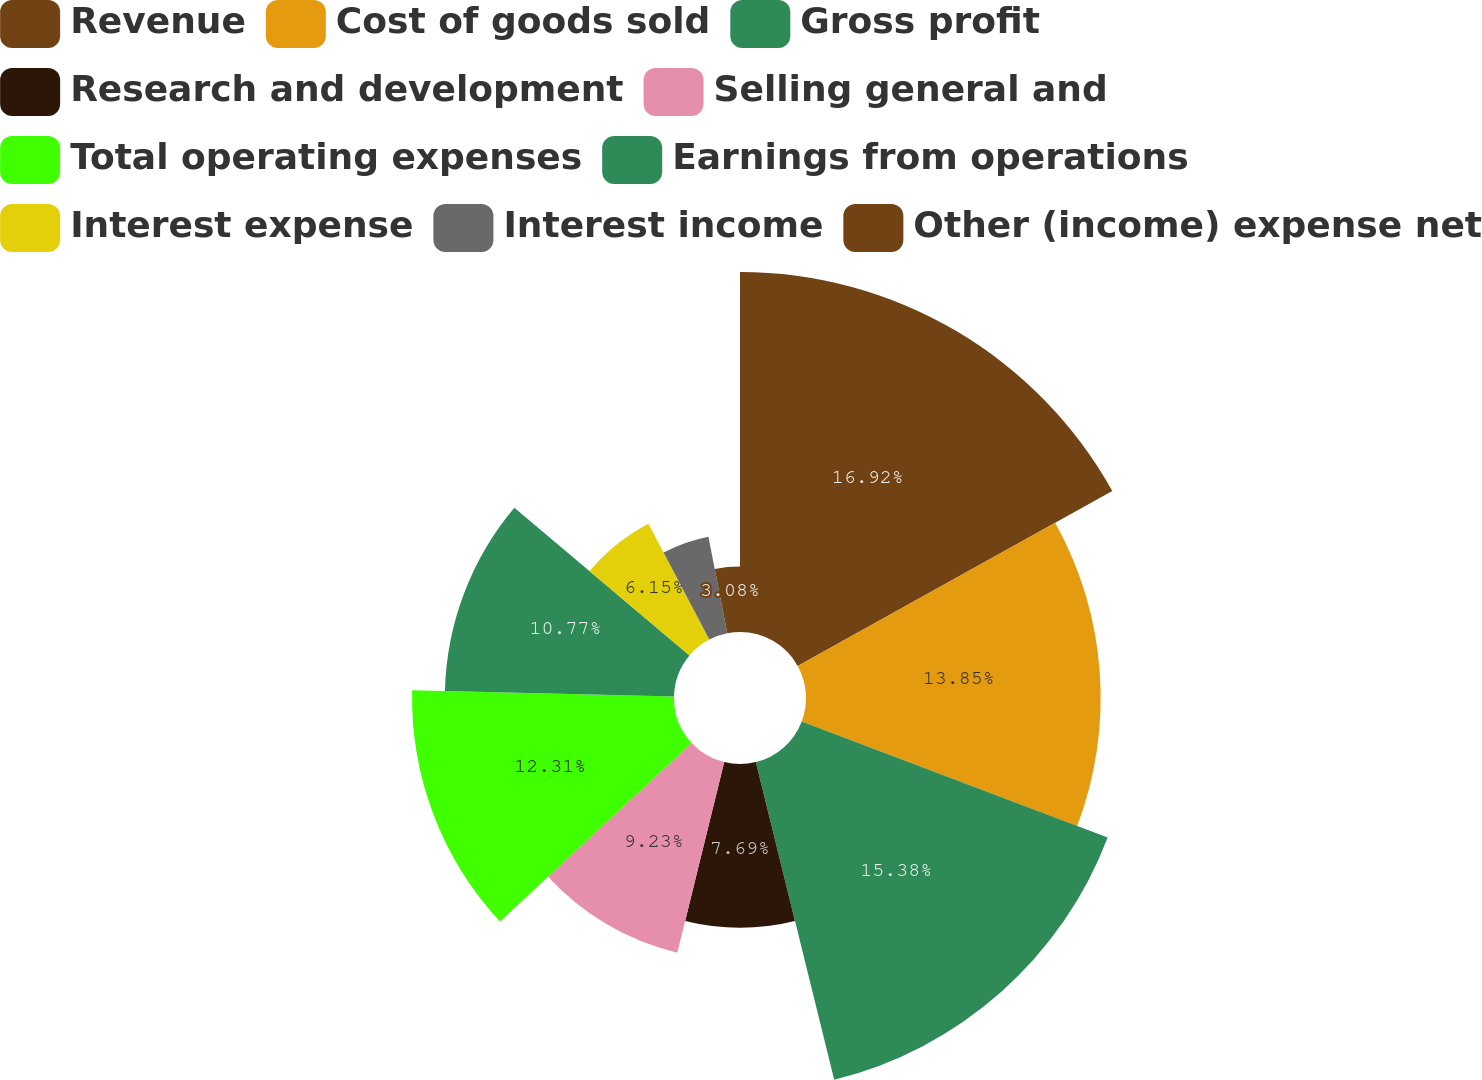<chart> <loc_0><loc_0><loc_500><loc_500><pie_chart><fcel>Revenue<fcel>Cost of goods sold<fcel>Gross profit<fcel>Research and development<fcel>Selling general and<fcel>Total operating expenses<fcel>Earnings from operations<fcel>Interest expense<fcel>Interest income<fcel>Other (income) expense net<nl><fcel>16.92%<fcel>13.85%<fcel>15.38%<fcel>7.69%<fcel>9.23%<fcel>12.31%<fcel>10.77%<fcel>6.15%<fcel>4.62%<fcel>3.08%<nl></chart> 